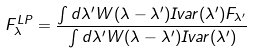<formula> <loc_0><loc_0><loc_500><loc_500>F ^ { L P } _ { \lambda } = \frac { \int d \lambda ^ { \prime } W ( \lambda - \lambda ^ { \prime } ) I v a r ( \lambda ^ { \prime } ) F _ { \lambda ^ { \prime } } } { \int d \lambda ^ { \prime } W ( \lambda - \lambda ^ { \prime } ) I v a r ( \lambda ^ { \prime } ) }</formula> 